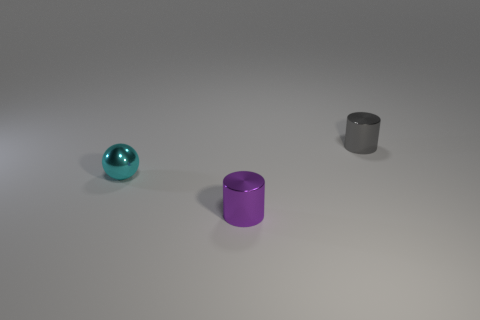Can you analyze the lighting and shadows in the image? Certainly. The image shows a soft and uniform lighting that casts gentle shadows directly underneath the objects, indicating that the light source is likely positioned above. The shadows are slightly elongated towards the right which suggests the light may be coming from the left side at a slight angle. The subtlety of the shadows implies that the lighting is diffused, reducing harsh lines and creating a calm and even aesthetic. 